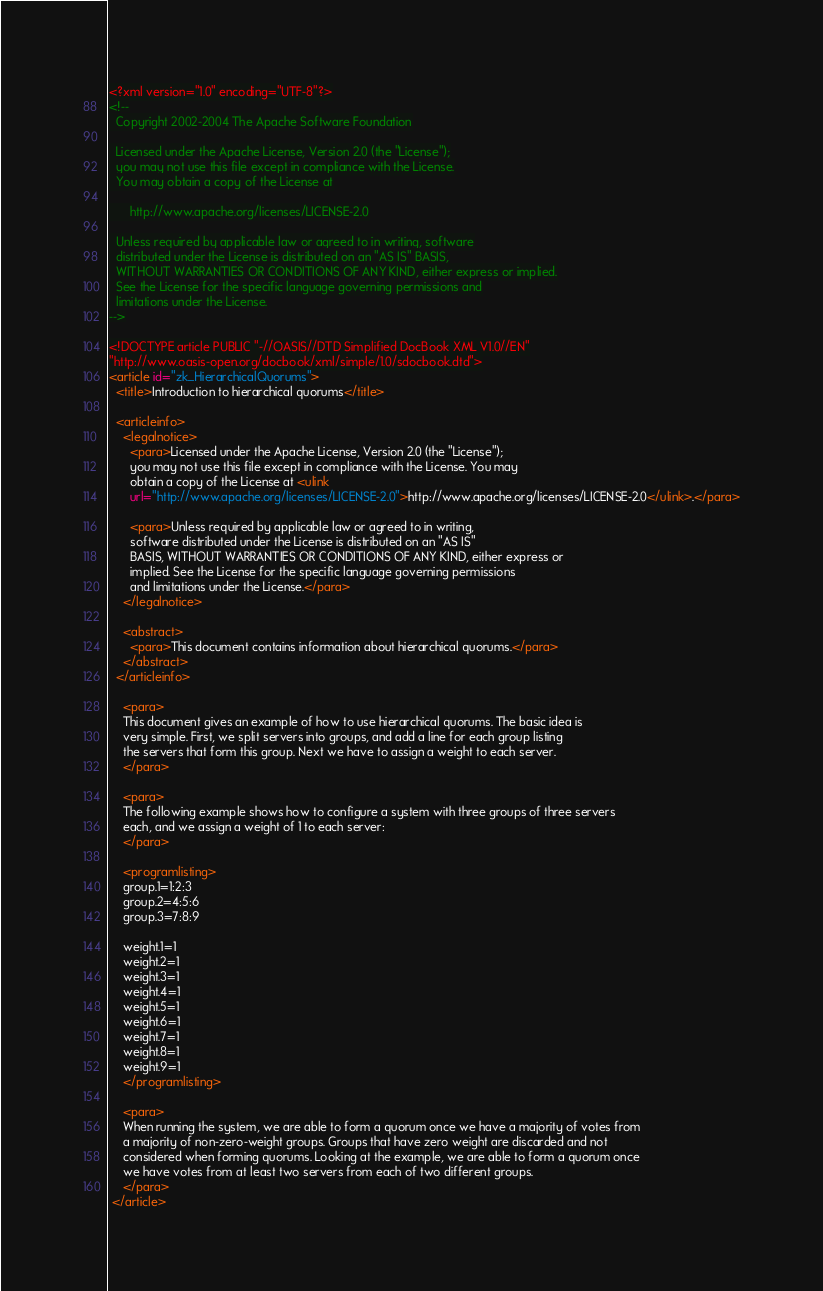Convert code to text. <code><loc_0><loc_0><loc_500><loc_500><_XML_><?xml version="1.0" encoding="UTF-8"?>
<!--
  Copyright 2002-2004 The Apache Software Foundation

  Licensed under the Apache License, Version 2.0 (the "License");
  you may not use this file except in compliance with the License.
  You may obtain a copy of the License at

      http://www.apache.org/licenses/LICENSE-2.0

  Unless required by applicable law or agreed to in writing, software
  distributed under the License is distributed on an "AS IS" BASIS,
  WITHOUT WARRANTIES OR CONDITIONS OF ANY KIND, either express or implied.
  See the License for the specific language governing permissions and
  limitations under the License.
-->

<!DOCTYPE article PUBLIC "-//OASIS//DTD Simplified DocBook XML V1.0//EN"
"http://www.oasis-open.org/docbook/xml/simple/1.0/sdocbook.dtd">
<article id="zk_HierarchicalQuorums">
  <title>Introduction to hierarchical quorums</title>

  <articleinfo>
    <legalnotice>
      <para>Licensed under the Apache License, Version 2.0 (the "License");
      you may not use this file except in compliance with the License. You may
      obtain a copy of the License at <ulink
      url="http://www.apache.org/licenses/LICENSE-2.0">http://www.apache.org/licenses/LICENSE-2.0</ulink>.</para>

      <para>Unless required by applicable law or agreed to in writing,
      software distributed under the License is distributed on an "AS IS"
      BASIS, WITHOUT WARRANTIES OR CONDITIONS OF ANY KIND, either express or
      implied. See the License for the specific language governing permissions
      and limitations under the License.</para>
    </legalnotice>

    <abstract>
      <para>This document contains information about hierarchical quorums.</para>
    </abstract>
  </articleinfo>

    <para>
    This document gives an example of how to use hierarchical quorums. The basic idea is
    very simple. First, we split servers into groups, and add a line for each group listing
    the servers that form this group. Next we have to assign a weight to each server.  
    </para>
    
    <para>
    The following example shows how to configure a system with three groups of three servers
    each, and we assign a weight of 1 to each server:
    </para>
    
    <programlisting>
    group.1=1:2:3
    group.2=4:5:6
    group.3=7:8:9
   
    weight.1=1
    weight.2=1
    weight.3=1
    weight.4=1
    weight.5=1
    weight.6=1
    weight.7=1
    weight.8=1
    weight.9=1
 	</programlisting>

	<para>    
    When running the system, we are able to form a quorum once we have a majority of votes from
    a majority of non-zero-weight groups. Groups that have zero weight are discarded and not
    considered when forming quorums. Looking at the example, we are able to form a quorum once
    we have votes from at least two servers from each of two different groups.
    </para> 
 </article></code> 